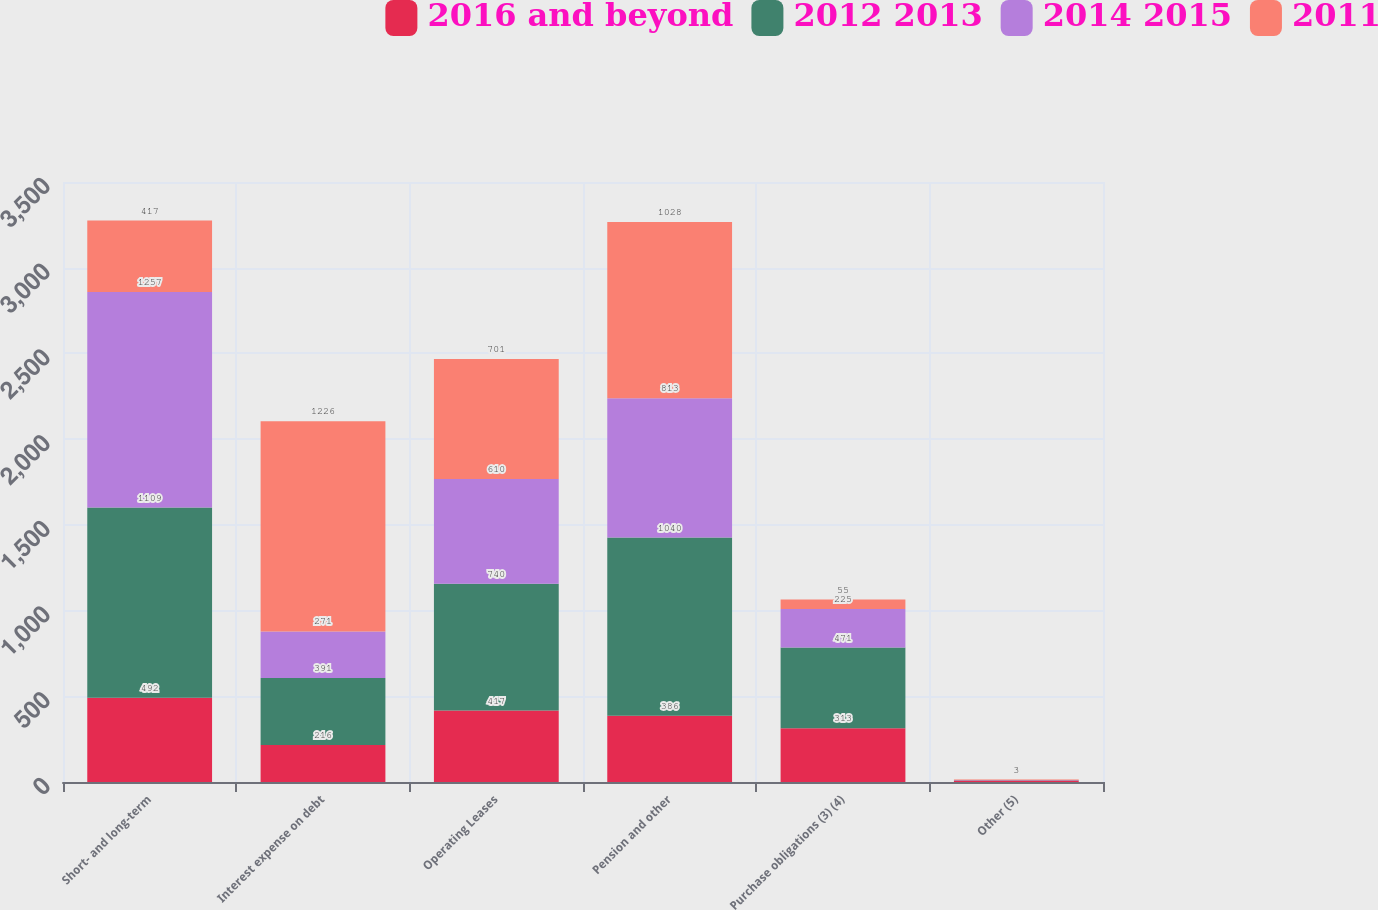<chart> <loc_0><loc_0><loc_500><loc_500><stacked_bar_chart><ecel><fcel>Short- and long-term<fcel>Interest expense on debt<fcel>Operating Leases<fcel>Pension and other<fcel>Purchase obligations (3) (4)<fcel>Other (5)<nl><fcel>2016 and beyond<fcel>492<fcel>216<fcel>417<fcel>386<fcel>313<fcel>9<nl><fcel>2012 2013<fcel>1109<fcel>391<fcel>740<fcel>1040<fcel>471<fcel>1<nl><fcel>2014 2015<fcel>1257<fcel>271<fcel>610<fcel>813<fcel>225<fcel>1<nl><fcel>2011<fcel>417<fcel>1226<fcel>701<fcel>1028<fcel>55<fcel>3<nl></chart> 